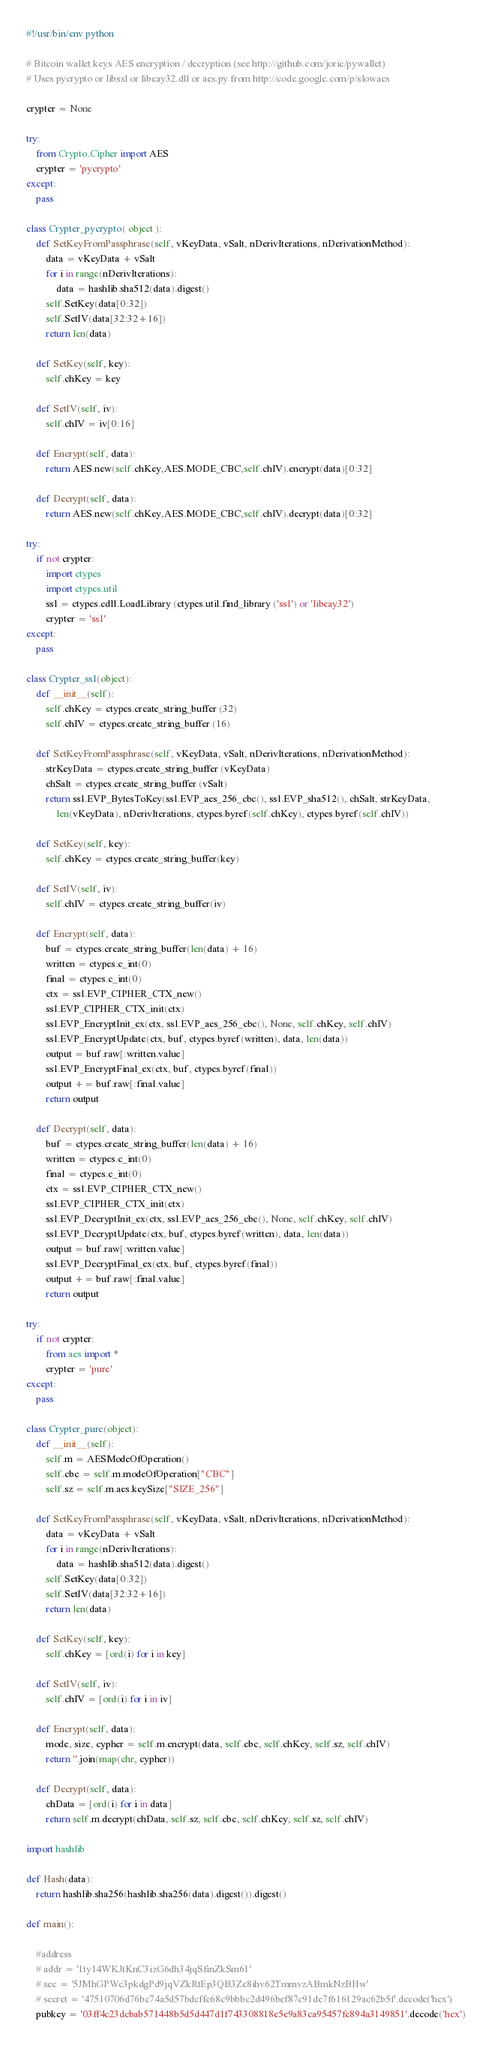Convert code to text. <code><loc_0><loc_0><loc_500><loc_500><_Python_>#!/usr/bin/env python

# Bitcoin wallet keys AES encryption / decryption (see http://github.com/joric/pywallet)
# Uses pycrypto or libssl or libeay32.dll or aes.py from http://code.google.com/p/slowaes

crypter = None

try:
    from Crypto.Cipher import AES
    crypter = 'pycrypto'
except:
    pass

class Crypter_pycrypto( object ):
    def SetKeyFromPassphrase(self, vKeyData, vSalt, nDerivIterations, nDerivationMethod):
        data = vKeyData + vSalt
        for i in range(nDerivIterations):
            data = hashlib.sha512(data).digest()
        self.SetKey(data[0:32])
        self.SetIV(data[32:32+16])
        return len(data)

    def SetKey(self, key):
        self.chKey = key

    def SetIV(self, iv):
        self.chIV = iv[0:16]

    def Encrypt(self, data):
        return AES.new(self.chKey,AES.MODE_CBC,self.chIV).encrypt(data)[0:32]

    def Decrypt(self, data):
        return AES.new(self.chKey,AES.MODE_CBC,self.chIV).decrypt(data)[0:32]

try:
    if not crypter:
        import ctypes
        import ctypes.util
        ssl = ctypes.cdll.LoadLibrary (ctypes.util.find_library ('ssl') or 'libeay32')
        crypter = 'ssl'
except:
    pass

class Crypter_ssl(object):
    def __init__(self):
        self.chKey = ctypes.create_string_buffer (32)
        self.chIV = ctypes.create_string_buffer (16)

    def SetKeyFromPassphrase(self, vKeyData, vSalt, nDerivIterations, nDerivationMethod):
        strKeyData = ctypes.create_string_buffer (vKeyData)
        chSalt = ctypes.create_string_buffer (vSalt)
        return ssl.EVP_BytesToKey(ssl.EVP_aes_256_cbc(), ssl.EVP_sha512(), chSalt, strKeyData,
            len(vKeyData), nDerivIterations, ctypes.byref(self.chKey), ctypes.byref(self.chIV))

    def SetKey(self, key):
        self.chKey = ctypes.create_string_buffer(key)

    def SetIV(self, iv):
        self.chIV = ctypes.create_string_buffer(iv)

    def Encrypt(self, data):
        buf = ctypes.create_string_buffer(len(data) + 16)
        written = ctypes.c_int(0)
        final = ctypes.c_int(0)
        ctx = ssl.EVP_CIPHER_CTX_new()
        ssl.EVP_CIPHER_CTX_init(ctx)
        ssl.EVP_EncryptInit_ex(ctx, ssl.EVP_aes_256_cbc(), None, self.chKey, self.chIV)
        ssl.EVP_EncryptUpdate(ctx, buf, ctypes.byref(written), data, len(data))
        output = buf.raw[:written.value]
        ssl.EVP_EncryptFinal_ex(ctx, buf, ctypes.byref(final))
        output += buf.raw[:final.value]
        return output

    def Decrypt(self, data):
        buf = ctypes.create_string_buffer(len(data) + 16)
        written = ctypes.c_int(0)
        final = ctypes.c_int(0)
        ctx = ssl.EVP_CIPHER_CTX_new()
        ssl.EVP_CIPHER_CTX_init(ctx)
        ssl.EVP_DecryptInit_ex(ctx, ssl.EVP_aes_256_cbc(), None, self.chKey, self.chIV)
        ssl.EVP_DecryptUpdate(ctx, buf, ctypes.byref(written), data, len(data))
        output = buf.raw[:written.value]
        ssl.EVP_DecryptFinal_ex(ctx, buf, ctypes.byref(final))
        output += buf.raw[:final.value]
        return output

try:
    if not crypter:
        from aes import *
        crypter = 'pure'
except:
    pass

class Crypter_pure(object):
    def __init__(self):
        self.m = AESModeOfOperation()
        self.cbc = self.m.modeOfOperation["CBC"]
        self.sz = self.m.aes.keySize["SIZE_256"]

    def SetKeyFromPassphrase(self, vKeyData, vSalt, nDerivIterations, nDerivationMethod):
        data = vKeyData + vSalt
        for i in range(nDerivIterations):
            data = hashlib.sha512(data).digest()
        self.SetKey(data[0:32])
        self.SetIV(data[32:32+16])
        return len(data)

    def SetKey(self, key):
        self.chKey = [ord(i) for i in key]

    def SetIV(self, iv):
        self.chIV = [ord(i) for i in iv]

    def Encrypt(self, data):
        mode, size, cypher = self.m.encrypt(data, self.cbc, self.chKey, self.sz, self.chIV)
        return ''.join(map(chr, cypher))

    def Decrypt(self, data):
        chData = [ord(i) for i in data]
        return self.m.decrypt(chData, self.sz, self.cbc, self.chKey, self.sz, self.chIV)

import hashlib

def Hash(data):
    return hashlib.sha256(hashlib.sha256(data).digest()).digest()

def main():

    #address
    # addr = '1ty14WKJtKnC3izG6dh34jqSfinZkSm61'
    # sec = '5JMhGPWc3pkdgPd9jqVZkRtEp3QB3Ze8ihv62TmmvzABmkNzBHw'
    # secret = '47510706d76bc74a5d57bdcffc68c9bbbc2d496bef87c91de7f616129ac62b5f'.decode('hex')
    pubkey = '03ff4c23dcbab571448b5d5d447d1f743308818e5e9a83ca95457fe894a3149851'.decode('hex')</code> 